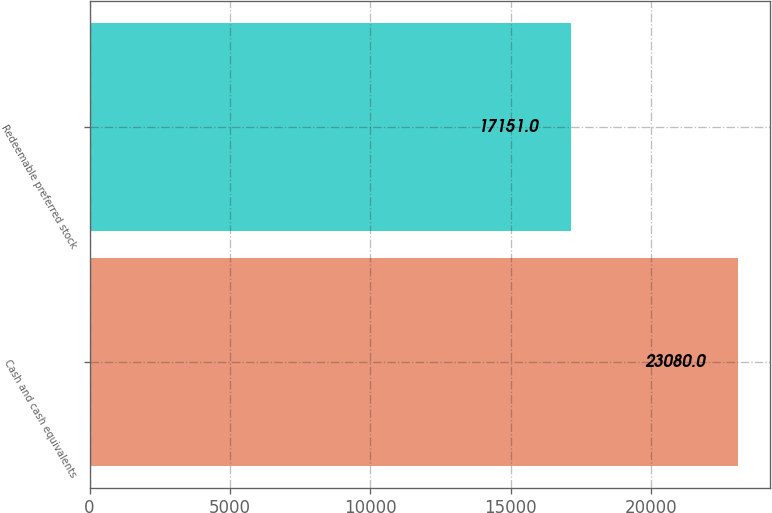Convert chart to OTSL. <chart><loc_0><loc_0><loc_500><loc_500><bar_chart><fcel>Cash and cash equivalents<fcel>Redeemable preferred stock<nl><fcel>23080<fcel>17151<nl></chart> 